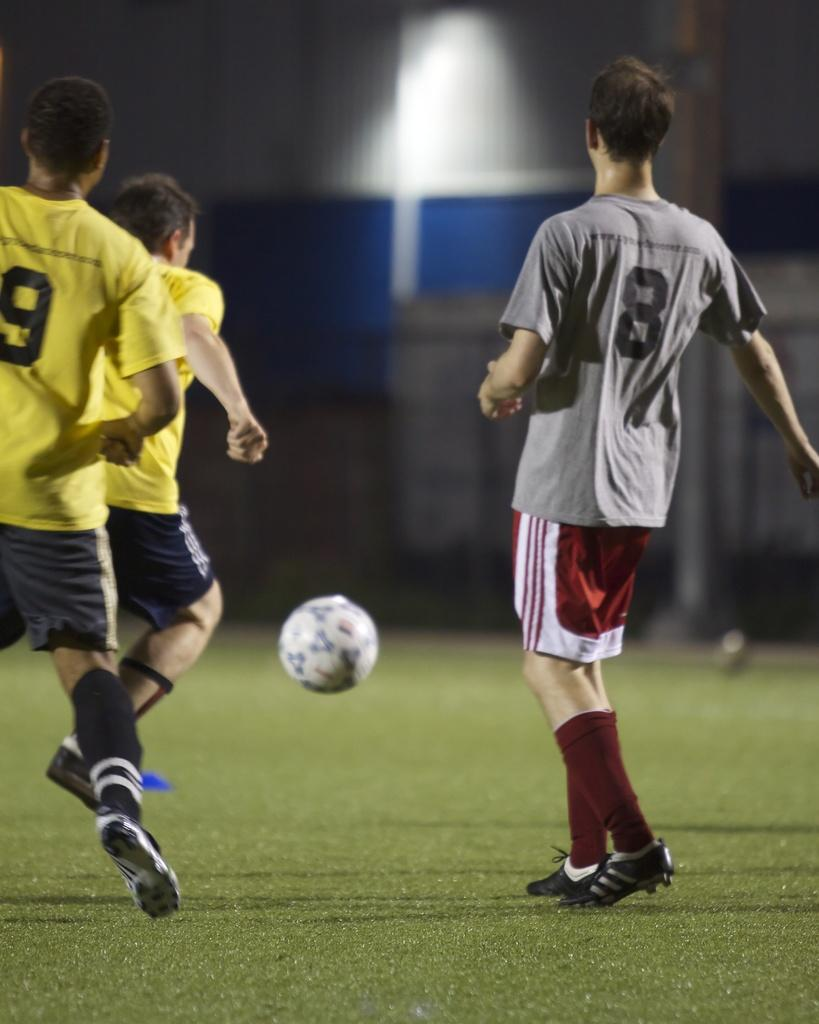What activity are the people in the image engaged in? The people in the image are playing football. What type of surface are they playing on? There is grass at the bottom of the image. What can be seen in the distance behind the people playing football? There is a building in the background of the image. What is the source of light in the background of the image? There is light visible in the background of the image. Can you see any signs of anger or frustration among the football players in the image? The image does not show any signs of anger or frustration among the football players; they appear to be engaged in the game. Is there a volcano present in the image? No, there is no volcano present in the image. 